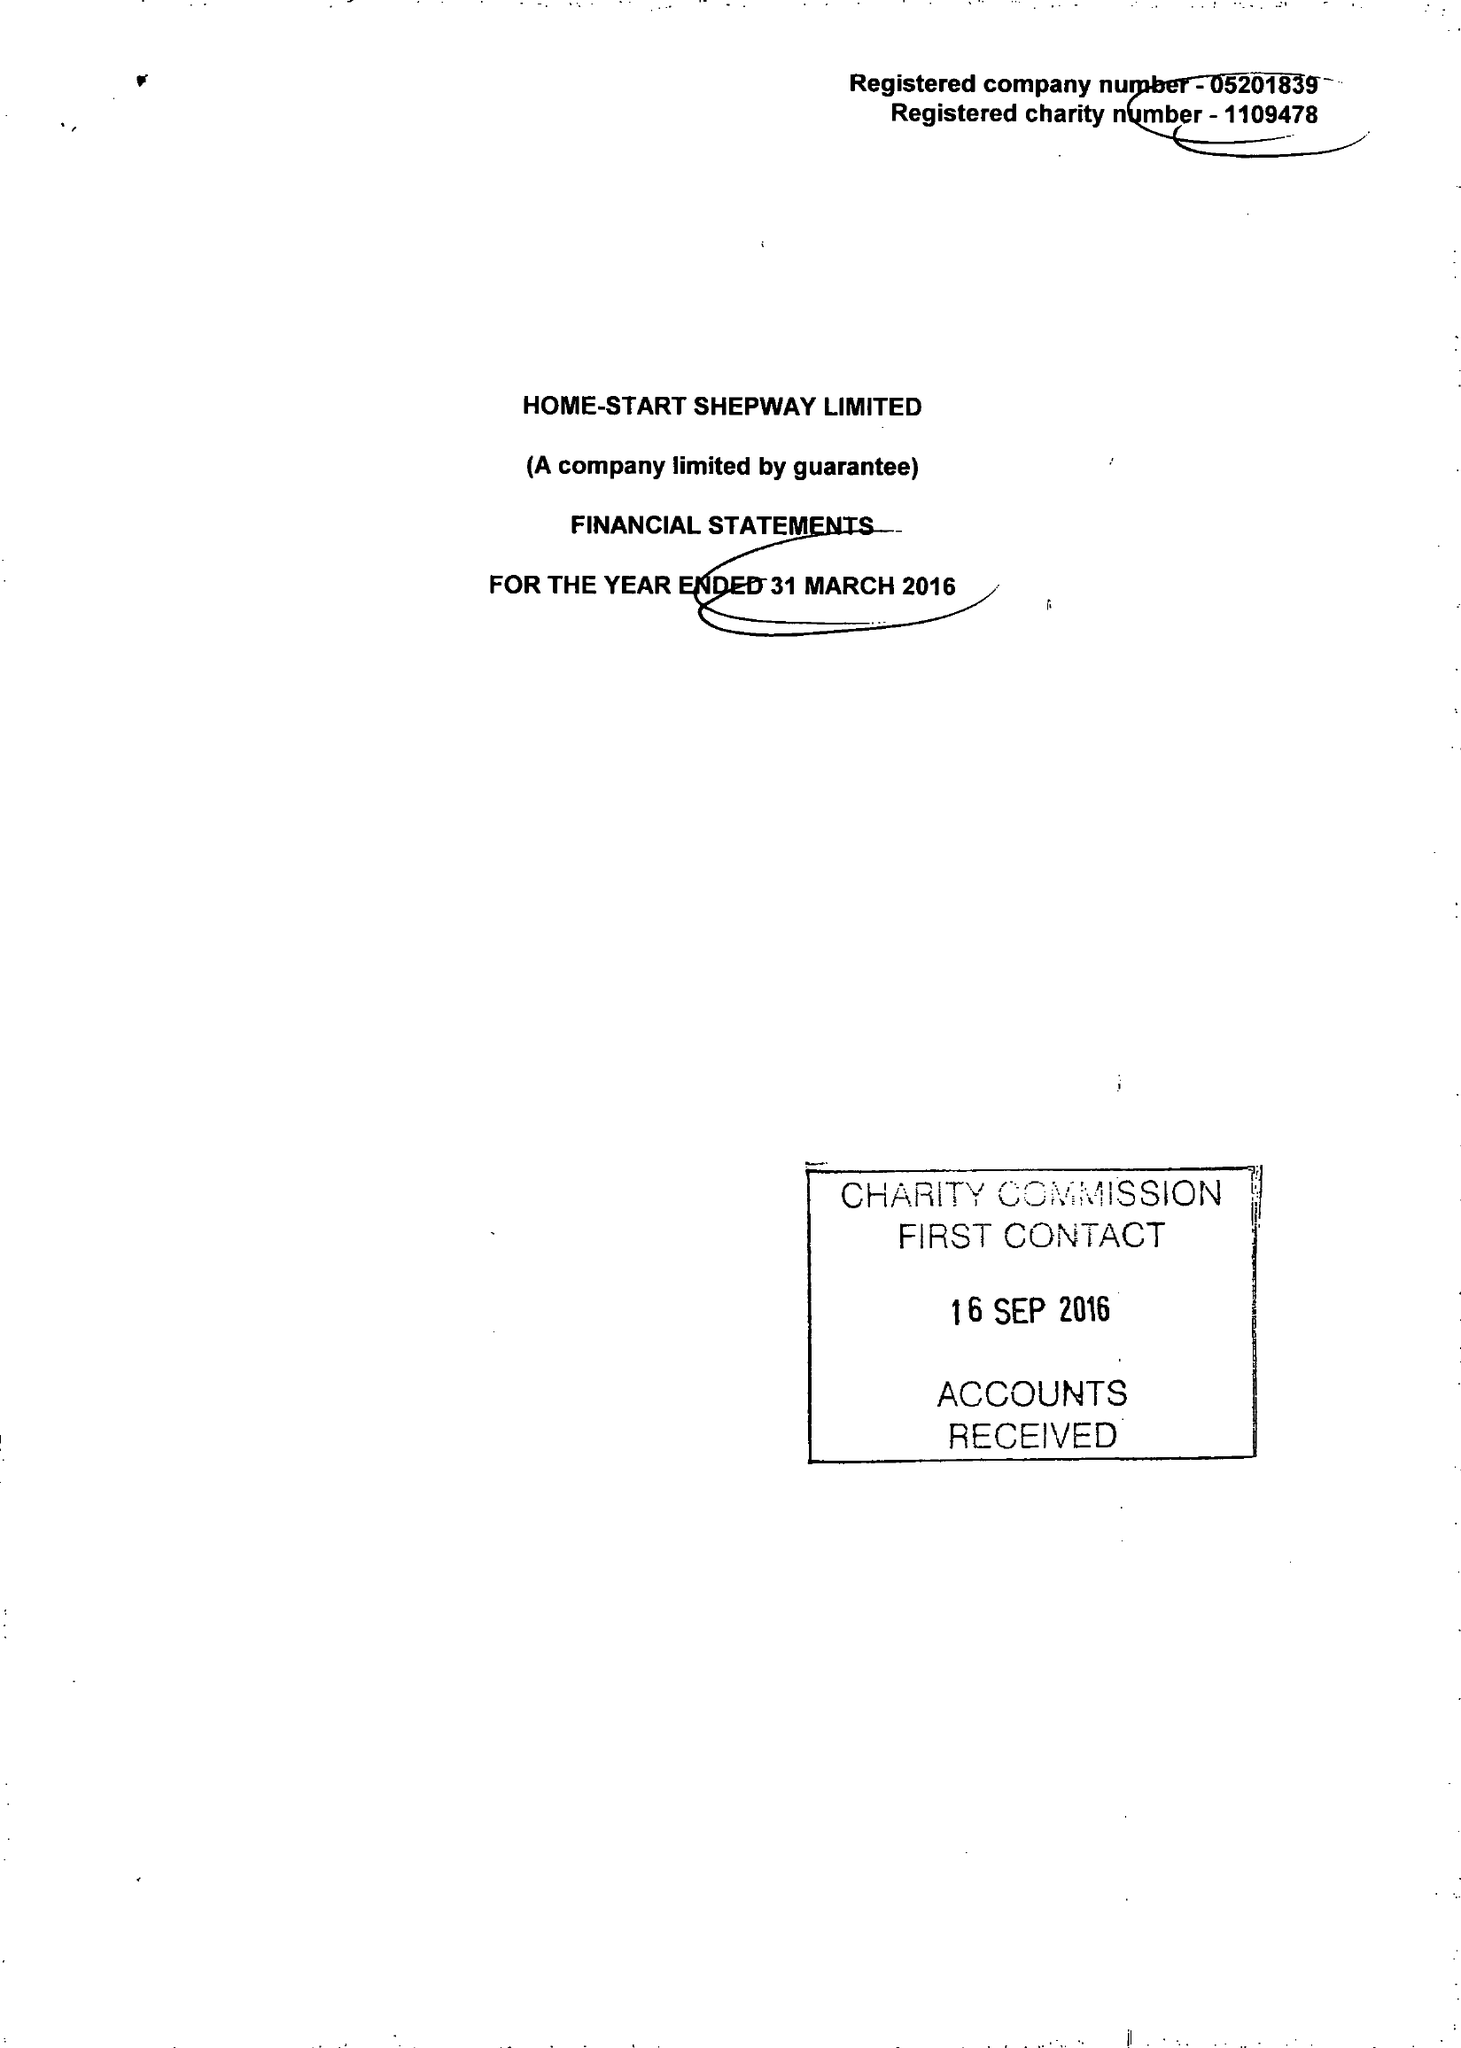What is the value for the address__street_line?
Answer the question using a single word or phrase. 24 CHERITON GARDENS 